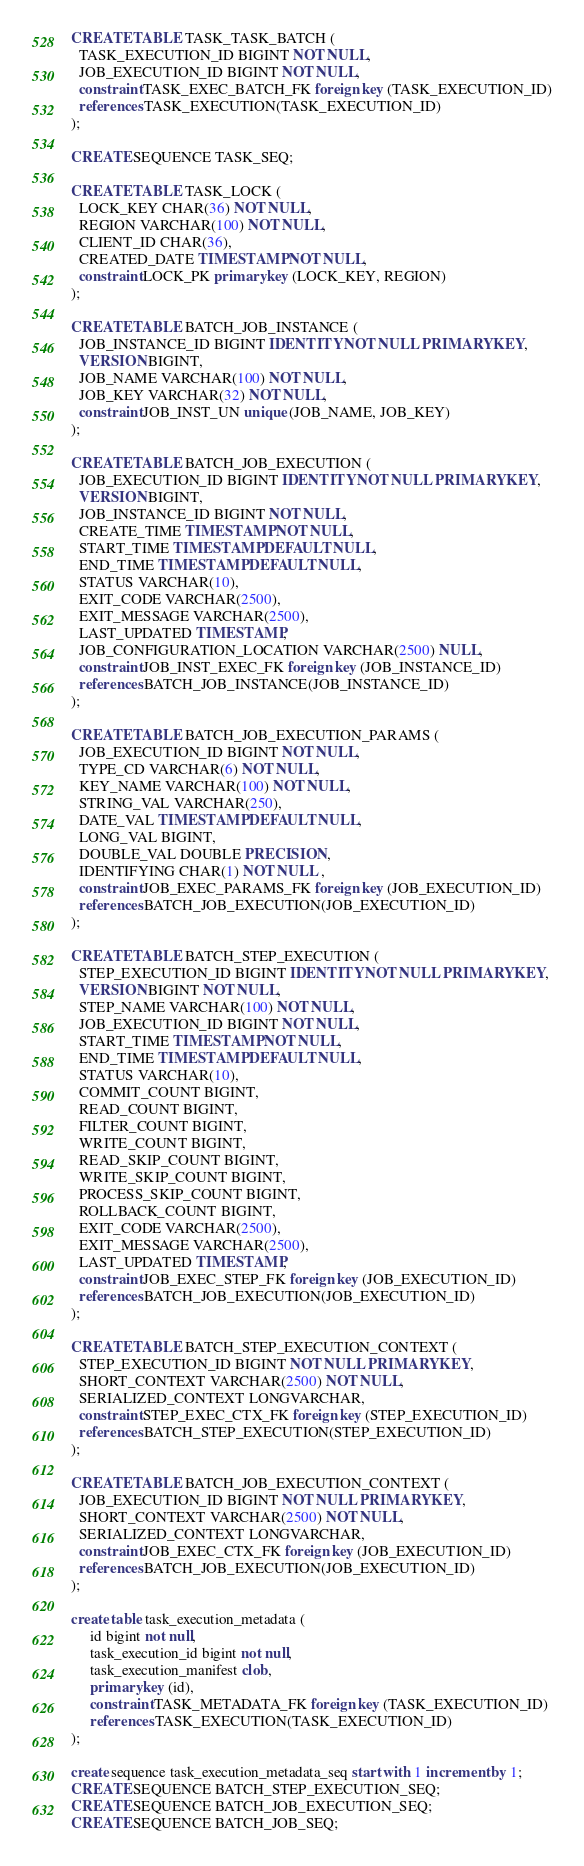<code> <loc_0><loc_0><loc_500><loc_500><_SQL_>CREATE TABLE TASK_TASK_BATCH (
  TASK_EXECUTION_ID BIGINT NOT NULL,
  JOB_EXECUTION_ID BIGINT NOT NULL,
  constraint TASK_EXEC_BATCH_FK foreign key (TASK_EXECUTION_ID)
  references TASK_EXECUTION(TASK_EXECUTION_ID)
);

CREATE SEQUENCE TASK_SEQ;

CREATE TABLE TASK_LOCK (
  LOCK_KEY CHAR(36) NOT NULL,
  REGION VARCHAR(100) NOT NULL,
  CLIENT_ID CHAR(36),
  CREATED_DATE TIMESTAMP NOT NULL,
  constraint LOCK_PK primary key (LOCK_KEY, REGION)
);

CREATE TABLE BATCH_JOB_INSTANCE (
  JOB_INSTANCE_ID BIGINT IDENTITY NOT NULL PRIMARY KEY,
  VERSION BIGINT,
  JOB_NAME VARCHAR(100) NOT NULL,
  JOB_KEY VARCHAR(32) NOT NULL,
  constraint JOB_INST_UN unique (JOB_NAME, JOB_KEY)
);

CREATE TABLE BATCH_JOB_EXECUTION (
  JOB_EXECUTION_ID BIGINT IDENTITY NOT NULL PRIMARY KEY,
  VERSION BIGINT,
  JOB_INSTANCE_ID BIGINT NOT NULL,
  CREATE_TIME TIMESTAMP NOT NULL,
  START_TIME TIMESTAMP DEFAULT NULL,
  END_TIME TIMESTAMP DEFAULT NULL,
  STATUS VARCHAR(10),
  EXIT_CODE VARCHAR(2500),
  EXIT_MESSAGE VARCHAR(2500),
  LAST_UPDATED TIMESTAMP,
  JOB_CONFIGURATION_LOCATION VARCHAR(2500) NULL,
  constraint JOB_INST_EXEC_FK foreign key (JOB_INSTANCE_ID)
  references BATCH_JOB_INSTANCE(JOB_INSTANCE_ID)
);

CREATE TABLE BATCH_JOB_EXECUTION_PARAMS (
  JOB_EXECUTION_ID BIGINT NOT NULL,
  TYPE_CD VARCHAR(6) NOT NULL,
  KEY_NAME VARCHAR(100) NOT NULL,
  STRING_VAL VARCHAR(250),
  DATE_VAL TIMESTAMP DEFAULT NULL,
  LONG_VAL BIGINT,
  DOUBLE_VAL DOUBLE PRECISION ,
  IDENTIFYING CHAR(1) NOT NULL ,
  constraint JOB_EXEC_PARAMS_FK foreign key (JOB_EXECUTION_ID)
  references BATCH_JOB_EXECUTION(JOB_EXECUTION_ID)
);

CREATE TABLE BATCH_STEP_EXECUTION (
  STEP_EXECUTION_ID BIGINT IDENTITY NOT NULL PRIMARY KEY,
  VERSION BIGINT NOT NULL,
  STEP_NAME VARCHAR(100) NOT NULL,
  JOB_EXECUTION_ID BIGINT NOT NULL,
  START_TIME TIMESTAMP NOT NULL,
  END_TIME TIMESTAMP DEFAULT NULL,
  STATUS VARCHAR(10),
  COMMIT_COUNT BIGINT,
  READ_COUNT BIGINT,
  FILTER_COUNT BIGINT,
  WRITE_COUNT BIGINT,
  READ_SKIP_COUNT BIGINT,
  WRITE_SKIP_COUNT BIGINT,
  PROCESS_SKIP_COUNT BIGINT,
  ROLLBACK_COUNT BIGINT,
  EXIT_CODE VARCHAR(2500),
  EXIT_MESSAGE VARCHAR(2500),
  LAST_UPDATED TIMESTAMP,
  constraint JOB_EXEC_STEP_FK foreign key (JOB_EXECUTION_ID)
  references BATCH_JOB_EXECUTION(JOB_EXECUTION_ID)
);

CREATE TABLE BATCH_STEP_EXECUTION_CONTEXT (
  STEP_EXECUTION_ID BIGINT NOT NULL PRIMARY KEY,
  SHORT_CONTEXT VARCHAR(2500) NOT NULL,
  SERIALIZED_CONTEXT LONGVARCHAR,
  constraint STEP_EXEC_CTX_FK foreign key (STEP_EXECUTION_ID)
  references BATCH_STEP_EXECUTION(STEP_EXECUTION_ID)
);

CREATE TABLE BATCH_JOB_EXECUTION_CONTEXT (
  JOB_EXECUTION_ID BIGINT NOT NULL PRIMARY KEY,
  SHORT_CONTEXT VARCHAR(2500) NOT NULL,
  SERIALIZED_CONTEXT LONGVARCHAR,
  constraint JOB_EXEC_CTX_FK foreign key (JOB_EXECUTION_ID)
  references BATCH_JOB_EXECUTION(JOB_EXECUTION_ID)
);

create table task_execution_metadata (
     id bigint not null,
     task_execution_id bigint not null,
     task_execution_manifest clob,
     primary key (id),
     constraint TASK_METADATA_FK foreign key (TASK_EXECUTION_ID)
     references TASK_EXECUTION(TASK_EXECUTION_ID)
);

create sequence task_execution_metadata_seq start with 1 increment by 1;
CREATE SEQUENCE BATCH_STEP_EXECUTION_SEQ;
CREATE SEQUENCE BATCH_JOB_EXECUTION_SEQ;
CREATE SEQUENCE BATCH_JOB_SEQ;
</code> 